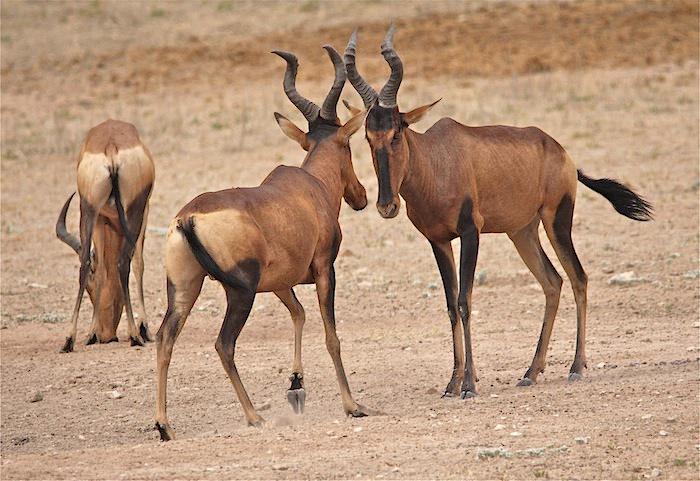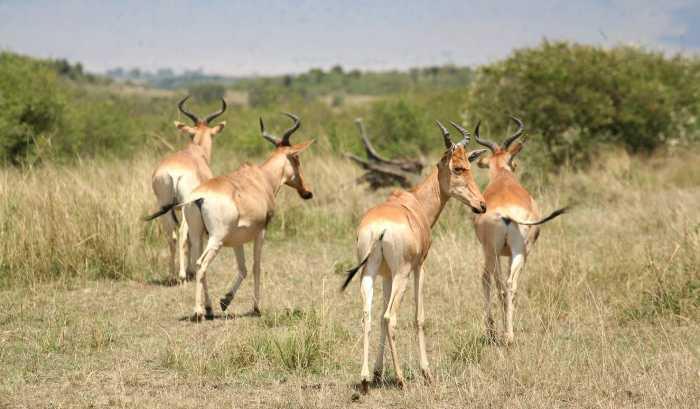The first image is the image on the left, the second image is the image on the right. Given the left and right images, does the statement "No photo contains more than one animal." hold true? Answer yes or no. No. 